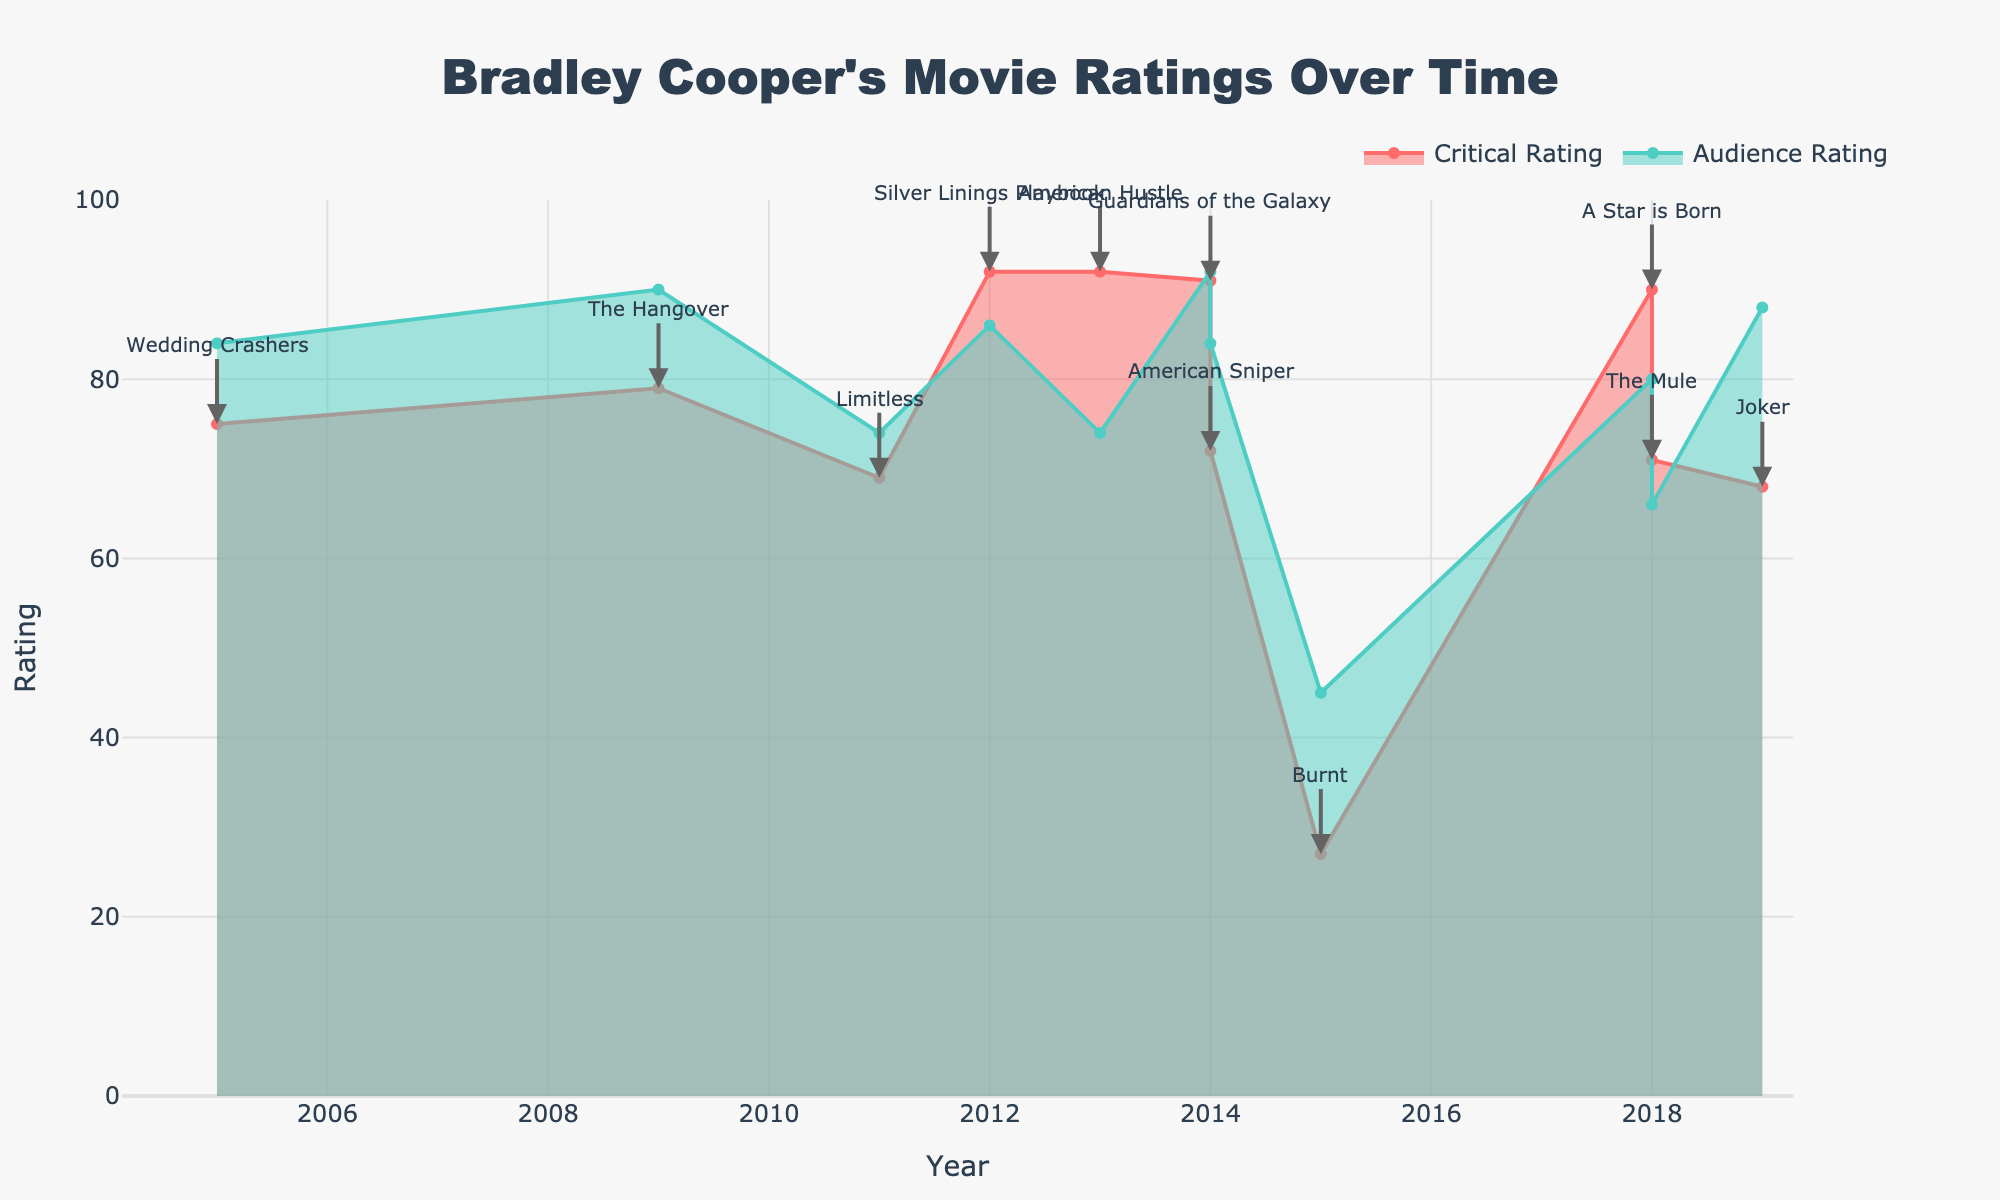What's the title of the plot? The title is prominently displayed at the top of the plot.
Answer: Bradley Cooper's Movie Ratings Over Time How many movies are shown in the figure? The figure includes data points for each movie, indicated by titles and markers on the plot. By counting the annotations, we find the total number of movies.
Answer: 11 Which movie had the highest critical rating? The critical ratings are represented by the red line. By looking for the peak in the red area, we find "Silver Linings Playbook" and "American Hustle" with the highest critical rating.
Answer: Silver Linings Playbook and American Hustle What year did "Guardians of the Galaxy" get released, and what were its critical and audience ratings? The annotations show the year of release. "Guardians of the Galaxy" is marked in the year 2014. The corresponding critical rating (red) is 91, and the audience rating (green) is 92.
Answer: 2014, Critical: 91, Audience: 92 Which movie has the largest discrepancy between critical and audience ratings? To find the largest discrepancy, we look for the movie with the greatest gap between the red line (critical) and green line (audience). This is "Burnt" with critical rating 27 and audience rating 45, showing the largest discrepancy of 18.
Answer: Burnt Did "A Star is Born" receive higher ratings from critics or audiences? The annotations show the movie titles. By comparing the values for "A Star is Born" at 2018, the critical rating is 90, and the audience rating is 80. The critical rating is higher.
Answer: Critics Which movie had the lowest audience rating, and what was this rating? The lowest audience rating is identified by looking for the lowest point on the green line. The annotation shows this as "Burnt" with an audience rating of 45.
Answer: Burnt, 45 In what year did Bradley Cooper appear in the most movies according to the figure, and how many movies did he star in that year? By looking at the x-axis for the year which has the most annotations, 2014 has two movies: "Guardians of the Galaxy" and "American Sniper".
Answer: 2014, 2 Compare the average critical ratings of movies before and after 2014. Are they higher or lower post-2014? To find the average critical ratings, we calculate the average for movies before 2014 and after 2014. Pre-2014: (75+79+69+92)/4 = 78.75. Post-2014: (92+91+72+27+90+71+68)/7 ≈ 72.86. The critical ratings are lower post-2014.
Answer: Lower What is the trend in audience ratings over time? By observing the green line (audience ratings) over time, we can see if it generally increases, decreases, or remains consistent. The trend shows fluctuation but no clear increasing or decreasing pattern.
Answer: Fluctuating 